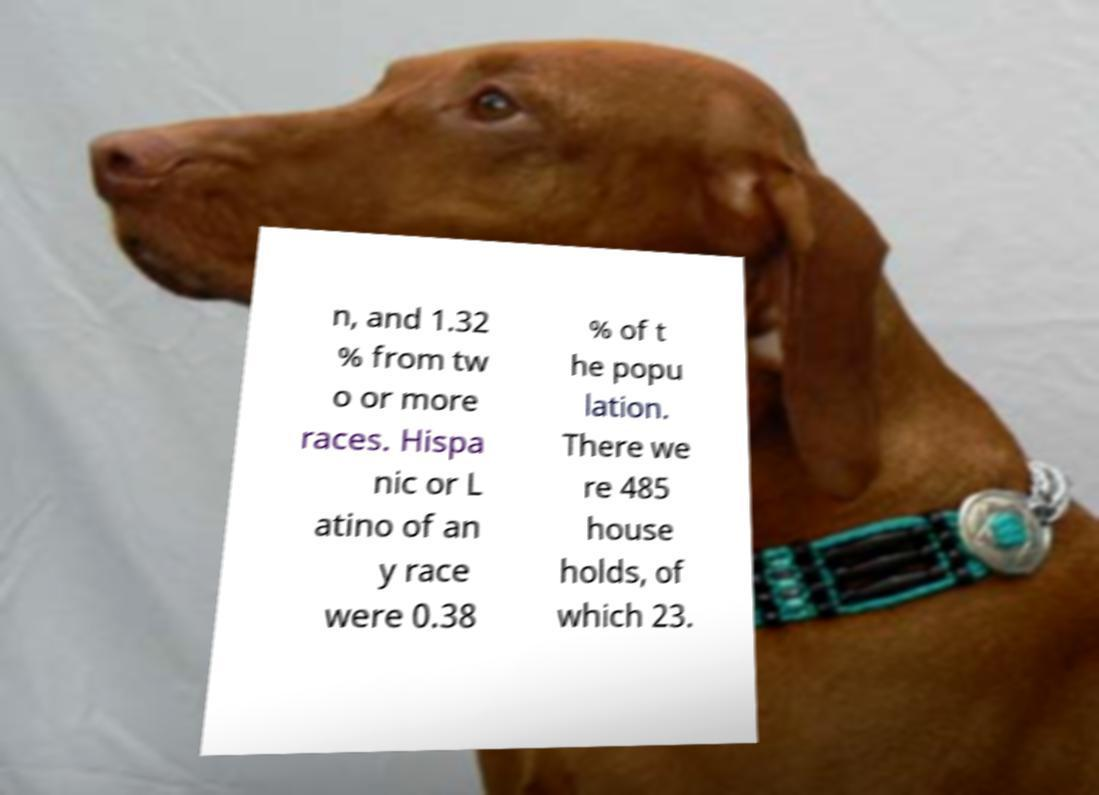There's text embedded in this image that I need extracted. Can you transcribe it verbatim? n, and 1.32 % from tw o or more races. Hispa nic or L atino of an y race were 0.38 % of t he popu lation. There we re 485 house holds, of which 23. 